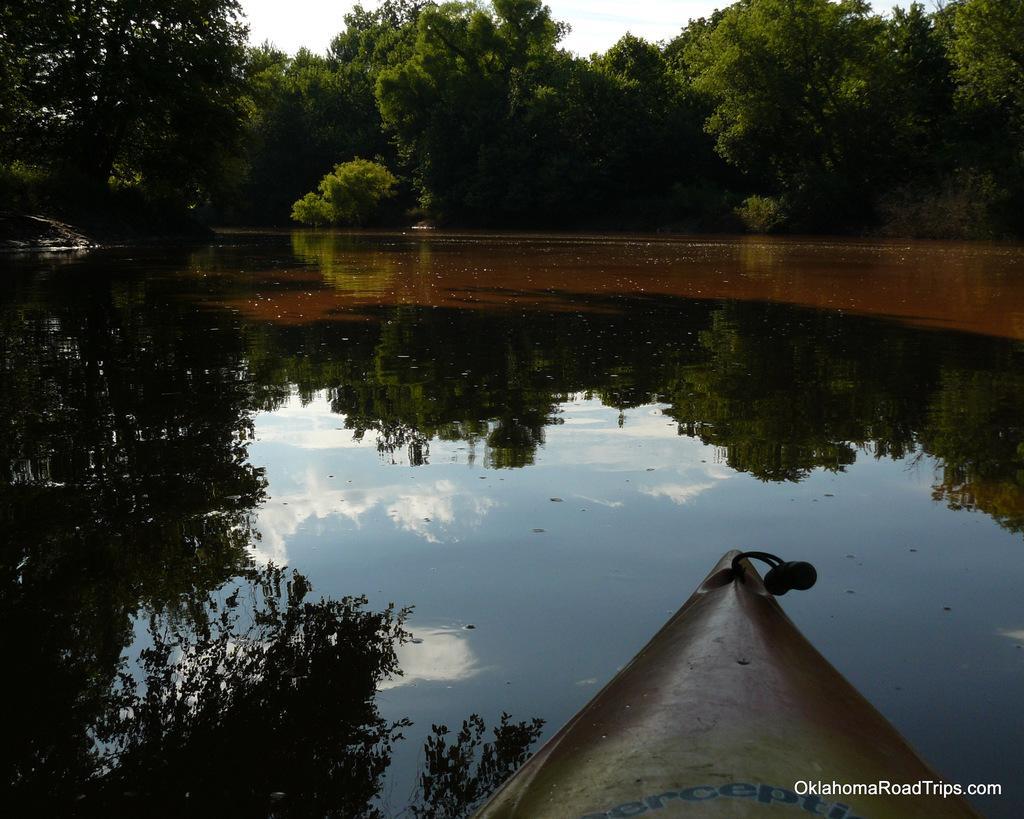Please provide a concise description of this image. This image consists of a pond or a lake. In the middle, there is water. At the bottom, there is a boat. In the background, there are many trees. At the top, there is sky. 